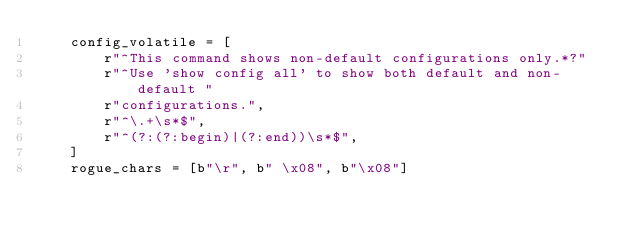<code> <loc_0><loc_0><loc_500><loc_500><_Python_>    config_volatile = [
        r"^This command shows non-default configurations only.*?"
        r"^Use 'show config all' to show both default and non-default "
        r"configurations.",
        r"^\.+\s*$",
        r"^(?:(?:begin)|(?:end))\s*$",
    ]
    rogue_chars = [b"\r", b" \x08", b"\x08"]
</code> 